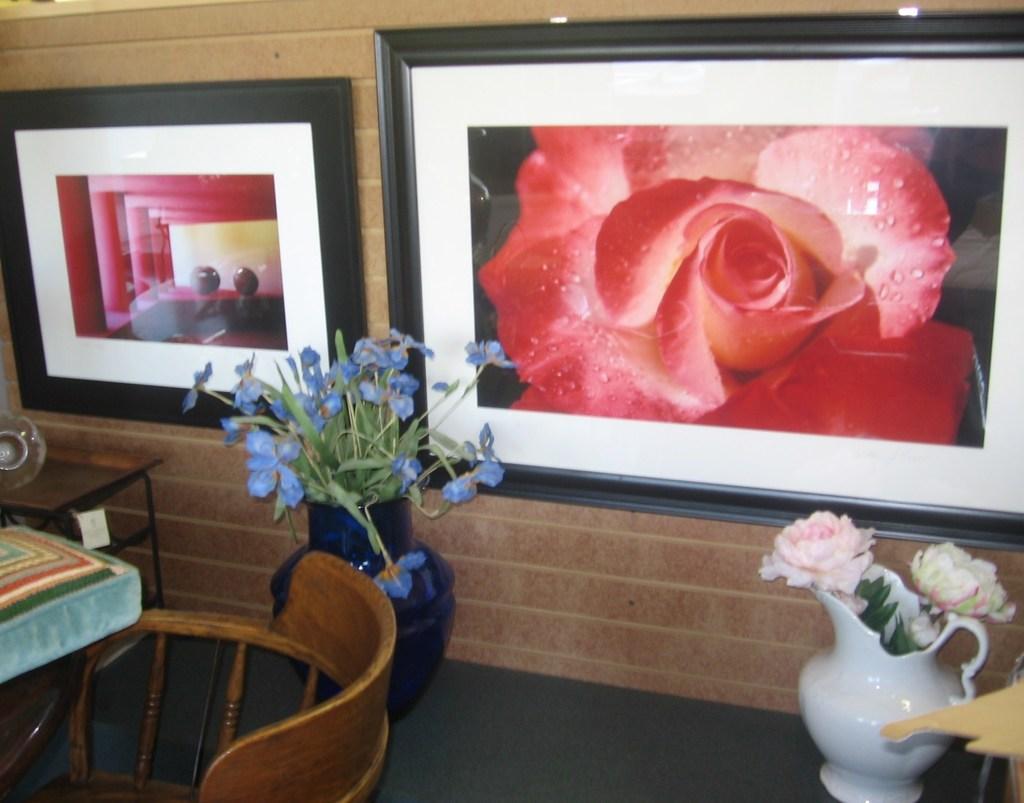Can you describe this image briefly? This picture shows two photo frames on the wall and to flower pots and we see a chair 